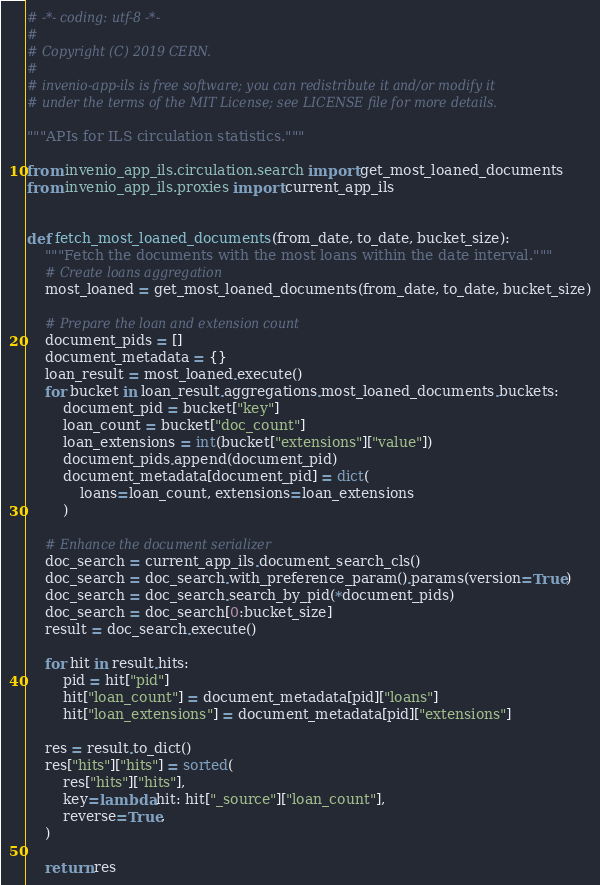<code> <loc_0><loc_0><loc_500><loc_500><_Python_># -*- coding: utf-8 -*-
#
# Copyright (C) 2019 CERN.
#
# invenio-app-ils is free software; you can redistribute it and/or modify it
# under the terms of the MIT License; see LICENSE file for more details.

"""APIs for ILS circulation statistics."""

from invenio_app_ils.circulation.search import get_most_loaned_documents
from invenio_app_ils.proxies import current_app_ils


def fetch_most_loaned_documents(from_date, to_date, bucket_size):
    """Fetch the documents with the most loans within the date interval."""
    # Create loans aggregation
    most_loaned = get_most_loaned_documents(from_date, to_date, bucket_size)

    # Prepare the loan and extension count
    document_pids = []
    document_metadata = {}
    loan_result = most_loaned.execute()
    for bucket in loan_result.aggregations.most_loaned_documents.buckets:
        document_pid = bucket["key"]
        loan_count = bucket["doc_count"]
        loan_extensions = int(bucket["extensions"]["value"])
        document_pids.append(document_pid)
        document_metadata[document_pid] = dict(
            loans=loan_count, extensions=loan_extensions
        )

    # Enhance the document serializer
    doc_search = current_app_ils.document_search_cls()
    doc_search = doc_search.with_preference_param().params(version=True)
    doc_search = doc_search.search_by_pid(*document_pids)
    doc_search = doc_search[0:bucket_size]
    result = doc_search.execute()

    for hit in result.hits:
        pid = hit["pid"]
        hit["loan_count"] = document_metadata[pid]["loans"]
        hit["loan_extensions"] = document_metadata[pid]["extensions"]

    res = result.to_dict()
    res["hits"]["hits"] = sorted(
        res["hits"]["hits"],
        key=lambda hit: hit["_source"]["loan_count"],
        reverse=True,
    )

    return res
</code> 